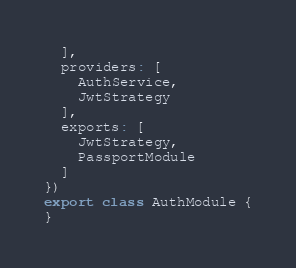<code> <loc_0><loc_0><loc_500><loc_500><_TypeScript_>  ],
  providers: [
    AuthService,
    JwtStrategy
  ],
  exports: [
    JwtStrategy,
    PassportModule
  ]
})
export class AuthModule {
}
</code> 